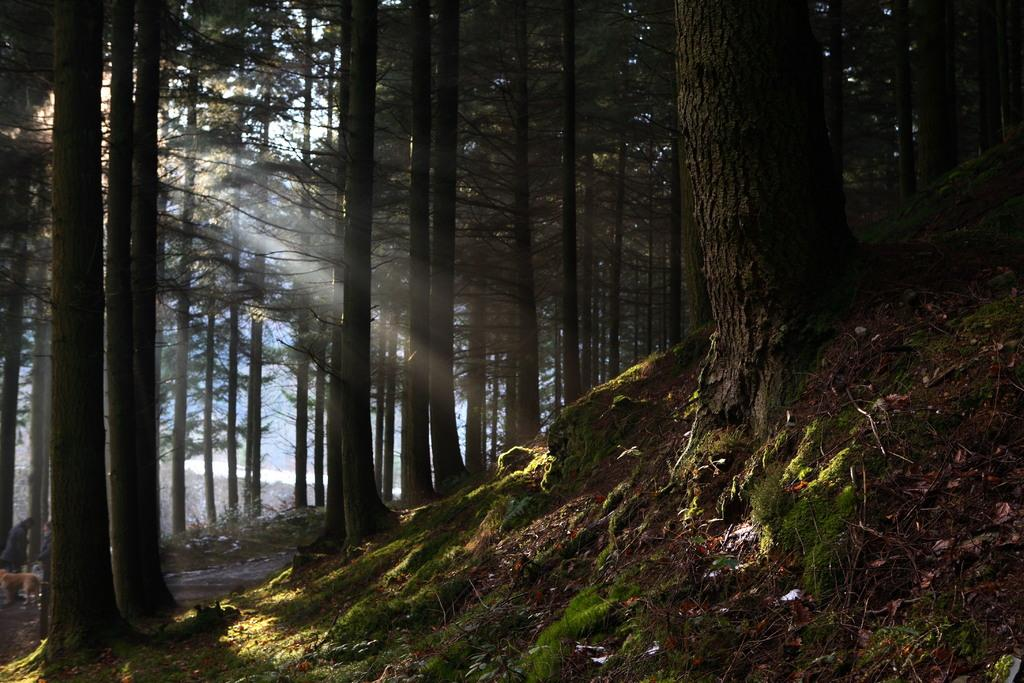What type of vegetation can be seen in the image? There are many trees in the image. What is covering the ground in the image? There is grass on the ground in the image. Can you tell me what type of bone is buried in the grass in the image? There is no bone present in the image; it only features trees and grass. Which direction is the watch pointing to in the image? There is no watch present in the image. 